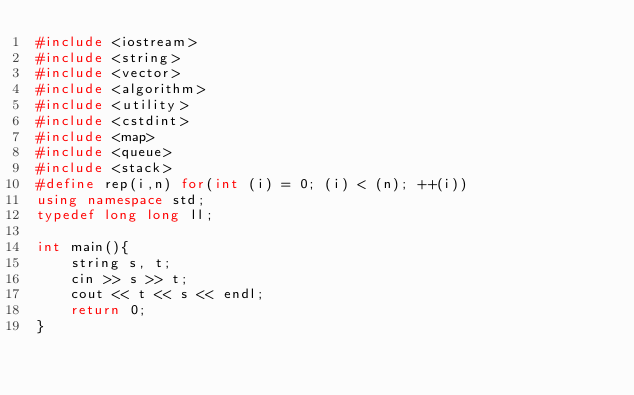<code> <loc_0><loc_0><loc_500><loc_500><_C++_>#include <iostream>
#include <string>
#include <vector>
#include <algorithm>
#include <utility>
#include <cstdint>
#include <map>
#include <queue>
#include <stack>
#define rep(i,n) for(int (i) = 0; (i) < (n); ++(i))
using namespace std;
typedef long long ll;

int main(){
    string s, t;
    cin >> s >> t;
    cout << t << s << endl;
    return 0;
}
</code> 